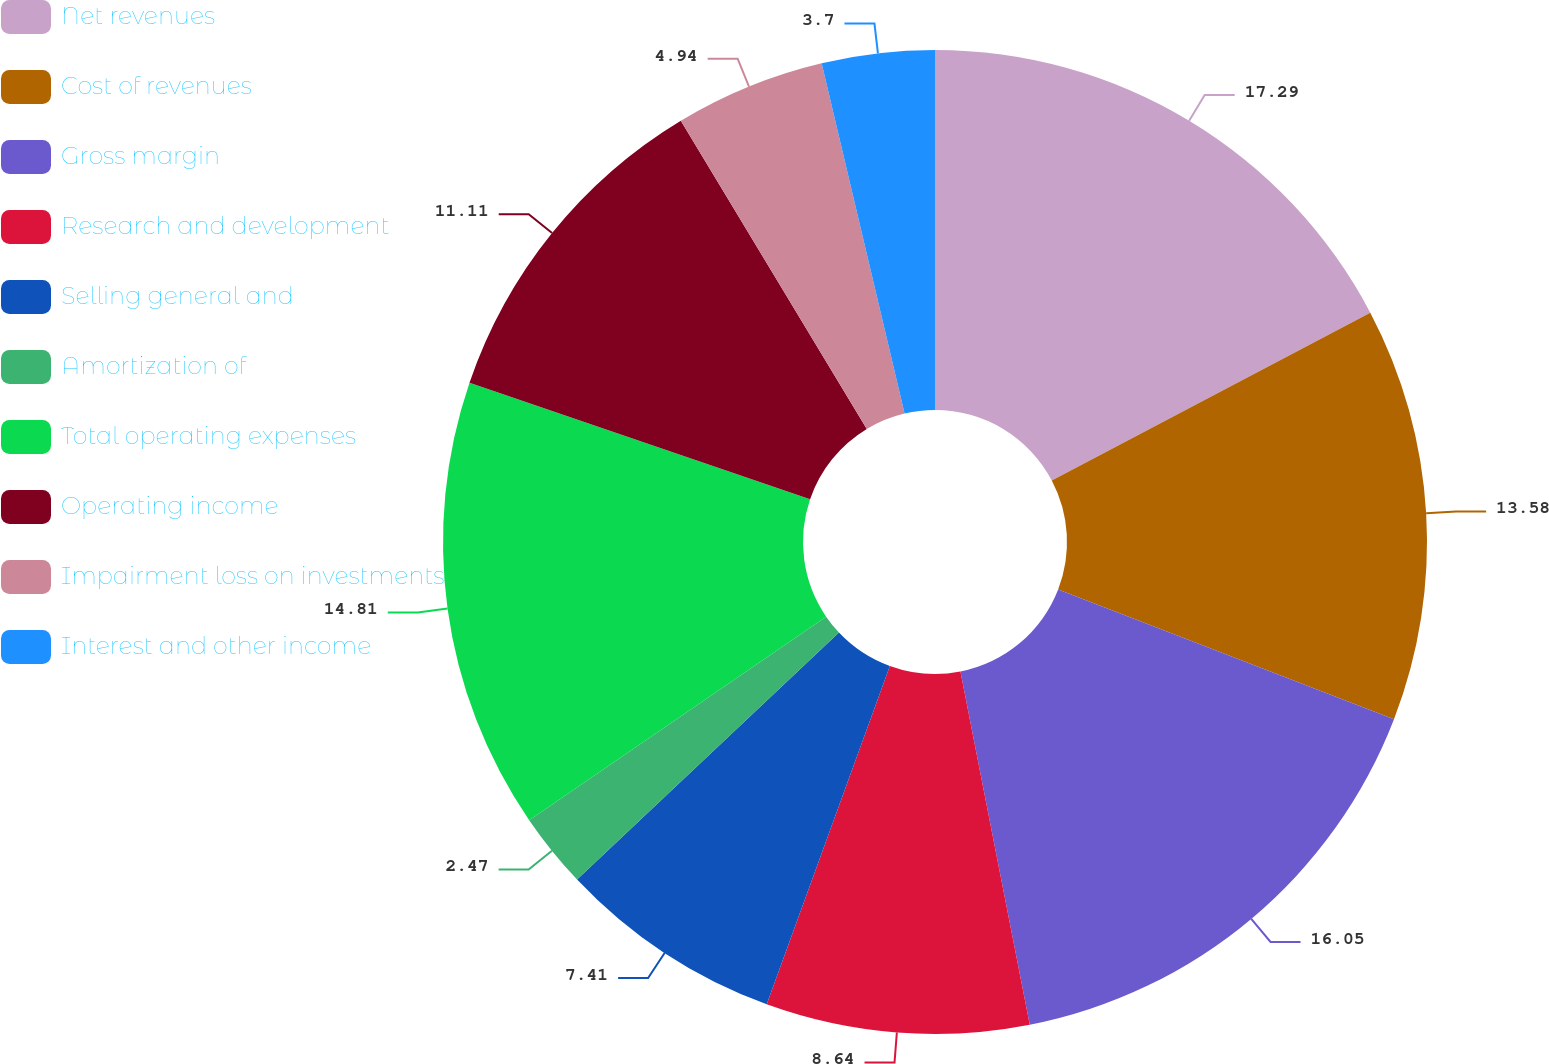Convert chart to OTSL. <chart><loc_0><loc_0><loc_500><loc_500><pie_chart><fcel>Net revenues<fcel>Cost of revenues<fcel>Gross margin<fcel>Research and development<fcel>Selling general and<fcel>Amortization of<fcel>Total operating expenses<fcel>Operating income<fcel>Impairment loss on investments<fcel>Interest and other income<nl><fcel>17.28%<fcel>13.58%<fcel>16.05%<fcel>8.64%<fcel>7.41%<fcel>2.47%<fcel>14.81%<fcel>11.11%<fcel>4.94%<fcel>3.7%<nl></chart> 